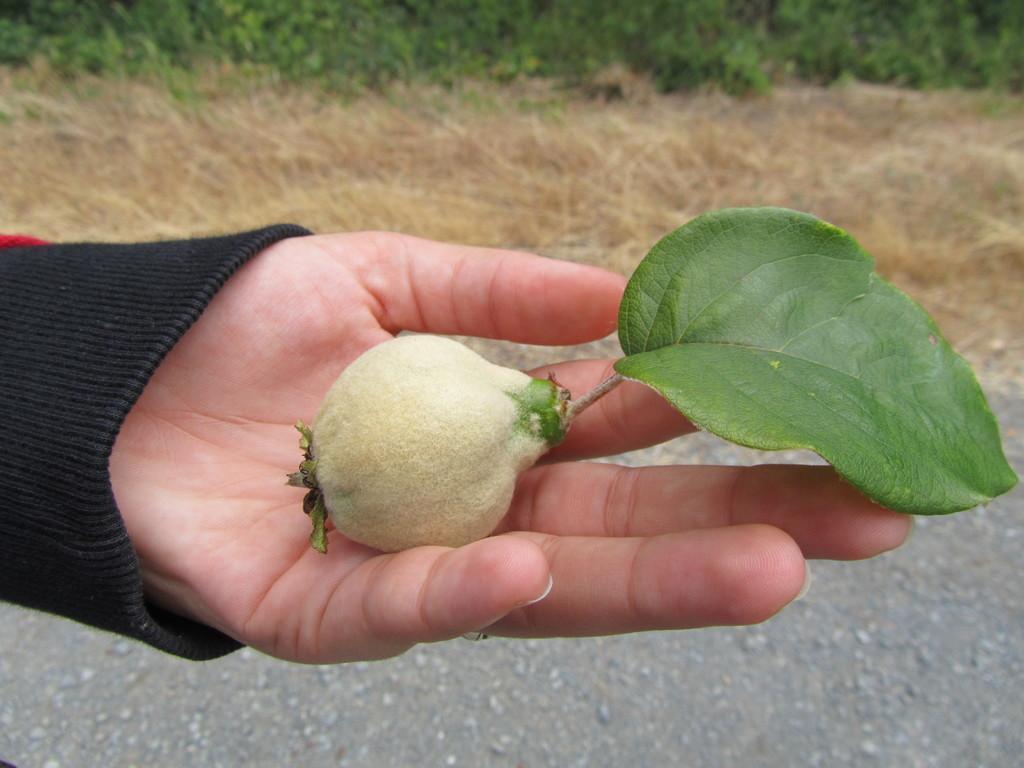How would you summarize this image in a sentence or two? In this picture we can observe a fruit in the human hand. There is a green color leaf. We can observe a road. In the background there is some dried grass and plants on the ground. 